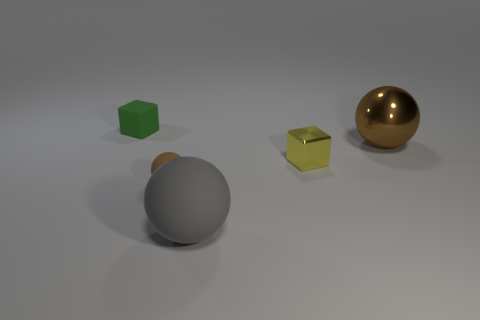What could these objects represent in a metaphoric or symbolic sense? Metaphorically, these objects could represent individuality and diversity, with each object having unique characteristics and coexisting within the same space. 